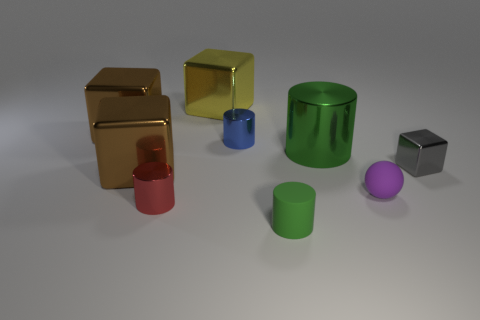Subtract all tiny blocks. How many blocks are left? 3 Add 1 small balls. How many objects exist? 10 Subtract all blue cylinders. How many cylinders are left? 3 Subtract all red cubes. Subtract all yellow balls. How many cubes are left? 4 Subtract all green blocks. How many brown cylinders are left? 0 Add 9 tiny green objects. How many tiny green objects exist? 10 Subtract 2 brown blocks. How many objects are left? 7 Subtract all cylinders. How many objects are left? 5 Subtract 3 cubes. How many cubes are left? 1 Subtract all blue rubber balls. Subtract all tiny blue metallic things. How many objects are left? 8 